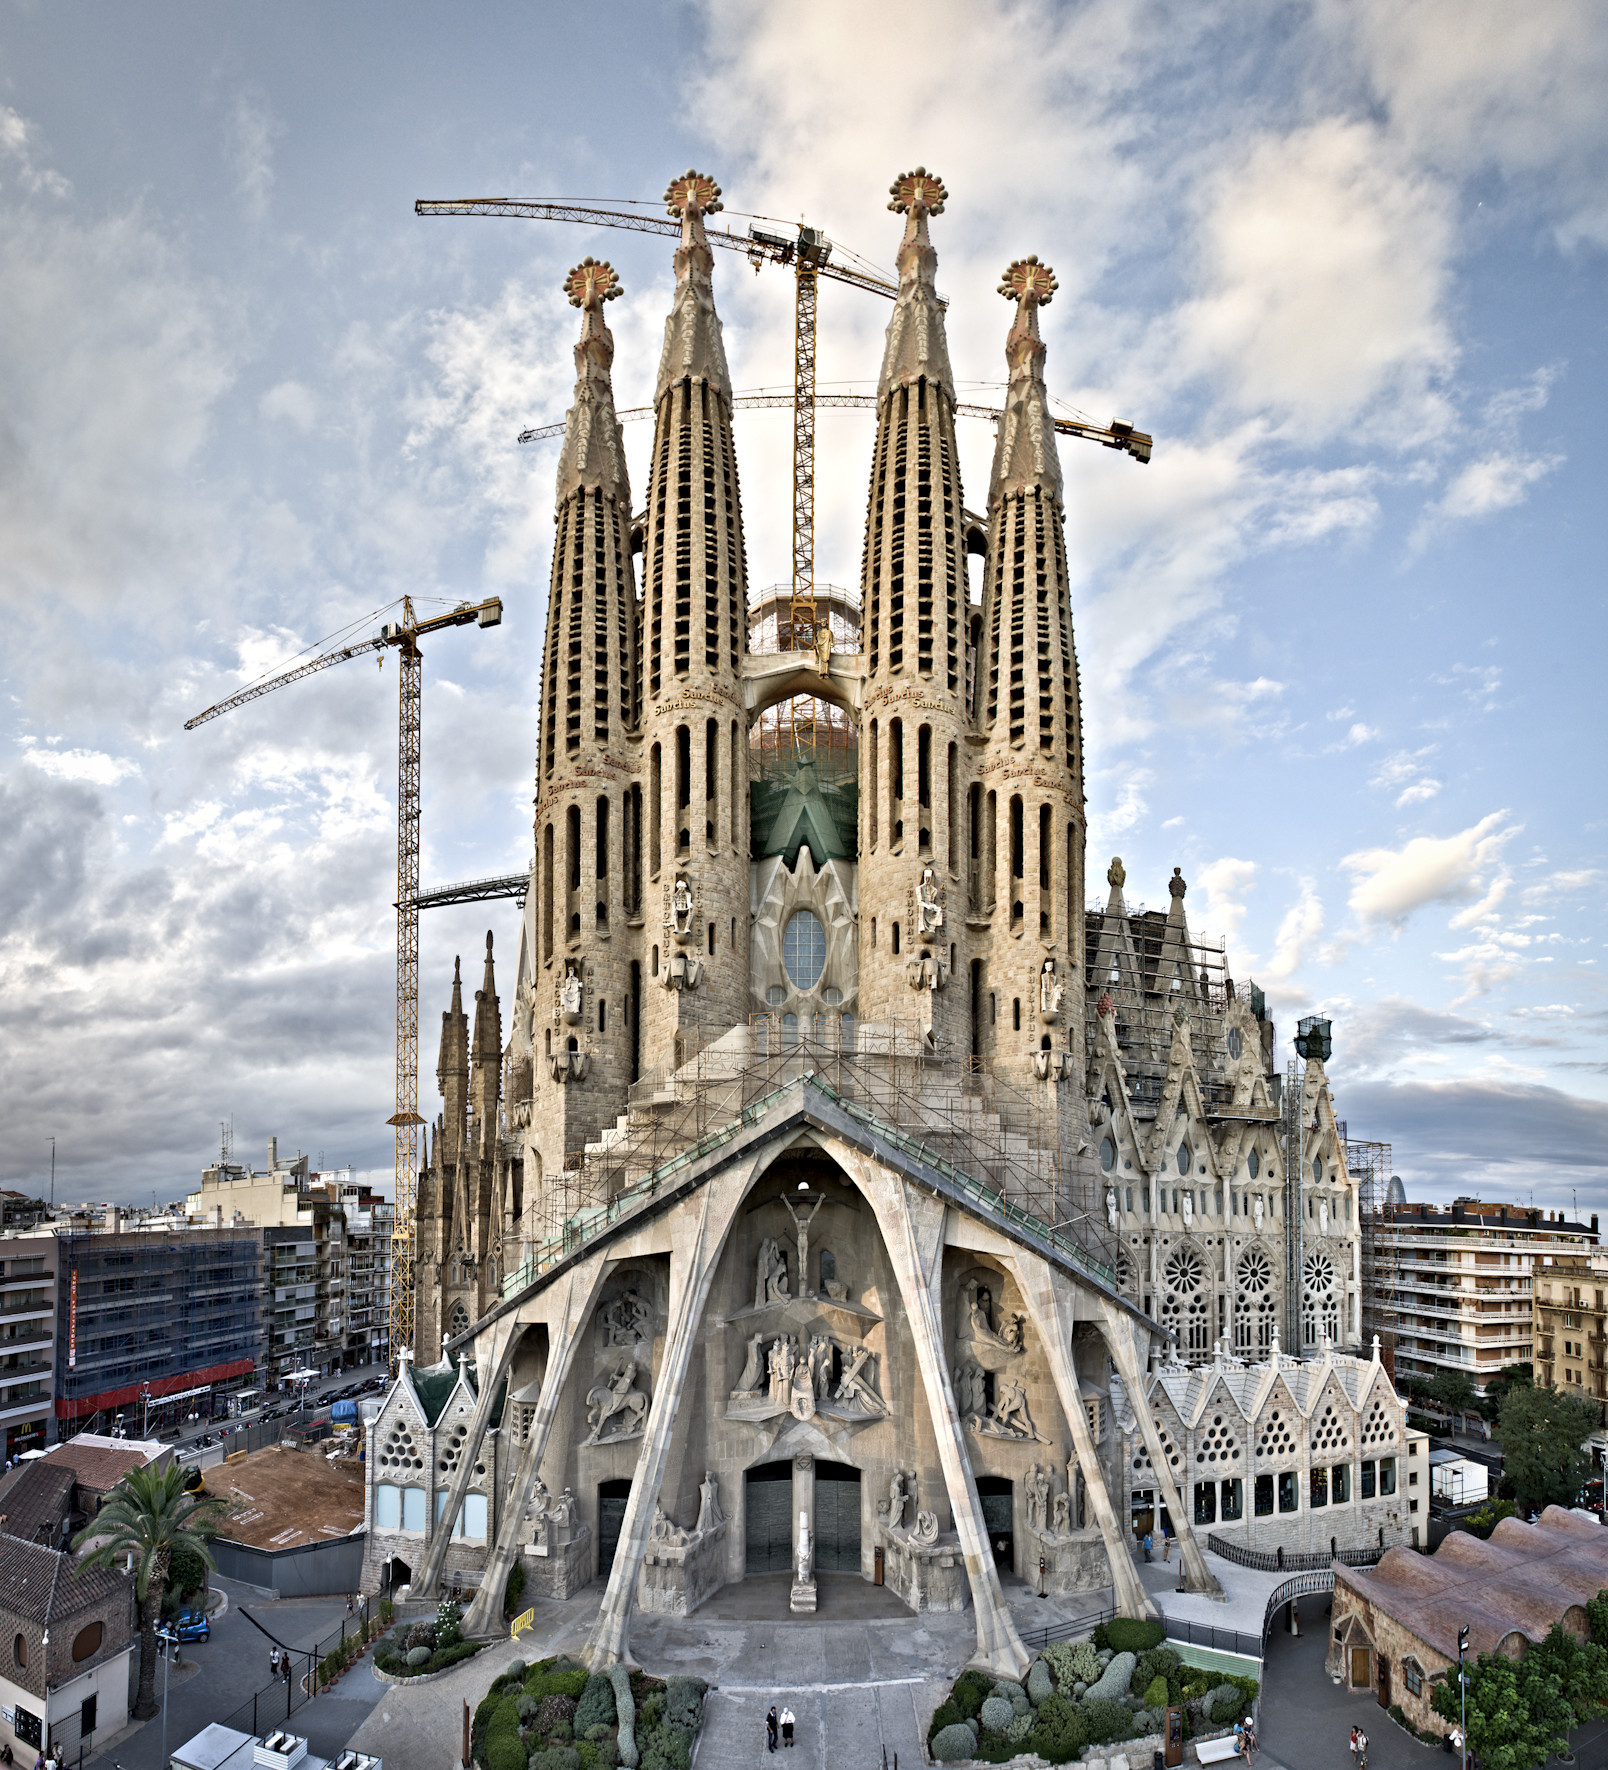Imagine if this church could speak. What stories might it tell about its construction? If the Sagrada Familia could speak, it would recount a tale of over a century of human endeavor, artistic vision, and unwavering faith. It would share stories of Antoni Gaudí, who dedicated the last years of his life to this project, working tirelessly to see his vision come to life. The church would speak of the challenge of construction during times of war, political upheaval, and economic hardship, each period leaving its mark on its walls.

It would also tell of the countless artisans, builders, and craftspeople who, despite knowing they might never see its completion, contributed their skills and passion to the ongoing creation of this masterpiece. The Sagrada Familia's story is one of perseverance, creativity, and the enduring human spirit striving for greatness. Can you describe a day in the life of a worker building this church? A day in the life of a worker at the Sagrada Familia begins early, with the city of Barcelona still waking up. Arriving at the site, they might start with a team briefing, discussing the tasks for the day and any challenges that need addressing. Equipped with safety gear, they scale scaffolds, operate cranes, and handle tools to carve intricate designs into stone or add to the network of structures rising skyward.

Throughout the day, their work is a blend of physical labor and artistic precision. They might pause to consult Gaudí's original plans, ensuring that each modern addition aligns with his vision. Breaks are often accompanied by the sounds of the bustling city and the sight of tourists marveling at the ongoing work. As the sun sets, the day's work concludes with a sense of accomplishment, contributing yet another piece to this monumental puzzle. 